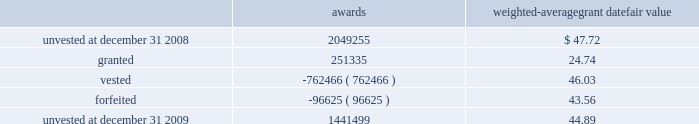Marathon oil corporation notes to consolidated financial statements restricted stock awards the following is a summary of restricted stock award activity .
Awards weighted-average grant date fair value .
The vesting date fair value of restricted stock awards which vested during 2009 , 2008 and 2007 was $ 24 million , $ 38 million and $ 29 million .
The weighted average grant date fair value of restricted stock awards was $ 44.89 , $ 47.72 , and $ 39.87 for awards unvested at december 31 , 2009 , 2008 and 2007 .
As of december 31 , 2009 , there was $ 43 million of unrecognized compensation cost related to restricted stock awards which is expected to be recognized over a weighted average period of 1.6 years .
Stock-based performance awards all stock-based performance awards have either vested or been forfeited .
The vesting date fair value of stock- based performance awards which vested during 2007 was $ 38 .
24 .
Stockholders 2019 equity in each year , 2009 and 2008 , we issued 2 million in common stock upon the redemption of the exchangeable shares described below in addition to treasury shares issued for employee stock-based awards .
The board of directors has authorized the repurchase of up to $ 5 billion of marathon common stock .
Purchases under the program may be in either open market transactions , including block purchases , or in privately negotiated transactions .
We will use cash on hand , cash generated from operations , proceeds from potential asset sales or cash from available borrowings to acquire shares .
This program may be changed based upon our financial condition or changes in market conditions and is subject to termination prior to completion .
The repurchase program does not include specific price targets or timetables .
As of december 31 , 2009 , we have acquired 66 million common shares at a cost of $ 2922 million under the program .
No shares have been acquired since august 2008 .
Securities exchangeable into marathon common stock 2013 as discussed in note 6 , we acquired all of the outstanding shares of western on october 18 , 2007 .
The western shareholders who were canadian residents received , at their election , cash , marathon common stock , securities exchangeable into marathon common stock ( the 201cexchangeable shares 201d ) or a combination thereof .
The western shareholders elected to receive 5 million exchangeable shares as part of the acquisition consideration .
The exchangeable shares are shares of an indirect canadian subsidiary of marathon and , at the acquisition date , were exchangeable on a one-for-one basis into marathon common stock .
Subsequent to the acquisition , the exchange ratio is adjusted to reflect cash dividends , if any , paid on marathon common stock and cash dividends , if any , paid on the exchangeable shares .
The exchange ratio at december 31 , 2009 , was 1.06109 common shares for each exchangeable share .
The exchangeable shares are exchangeable at the option of the holder at any time and are automatically redeemable on october 18 , 2011 .
Holders of exchangeable shares are entitled to instruct a trustee to vote ( or obtain a proxy from the trustee to vote directly ) on all matters submitted to the holders of marathon common stock .
The number of votes to which each holder is entitled is equal to the whole number of shares of marathon common stock into which such holder 2019s exchangeable shares would be exchangeable based on the exchange ratio in effect on the record date for the vote .
The voting right is attached to voting preferred shares of marathon that were issued to a trustee in an amount .
According to the above listed weighted average grant date fair value , by what percentage did the value of unvested restricted stock awards decrease from 2008 to 2009? 
Computations: (((1441499 * 44.89) - (2049255 * 47.72)) / (2049255 * 47.72))
Answer: -0.33829. Marathon oil corporation notes to consolidated financial statements restricted stock awards the following is a summary of restricted stock award activity .
Awards weighted-average grant date fair value .
The vesting date fair value of restricted stock awards which vested during 2009 , 2008 and 2007 was $ 24 million , $ 38 million and $ 29 million .
The weighted average grant date fair value of restricted stock awards was $ 44.89 , $ 47.72 , and $ 39.87 for awards unvested at december 31 , 2009 , 2008 and 2007 .
As of december 31 , 2009 , there was $ 43 million of unrecognized compensation cost related to restricted stock awards which is expected to be recognized over a weighted average period of 1.6 years .
Stock-based performance awards all stock-based performance awards have either vested or been forfeited .
The vesting date fair value of stock- based performance awards which vested during 2007 was $ 38 .
24 .
Stockholders 2019 equity in each year , 2009 and 2008 , we issued 2 million in common stock upon the redemption of the exchangeable shares described below in addition to treasury shares issued for employee stock-based awards .
The board of directors has authorized the repurchase of up to $ 5 billion of marathon common stock .
Purchases under the program may be in either open market transactions , including block purchases , or in privately negotiated transactions .
We will use cash on hand , cash generated from operations , proceeds from potential asset sales or cash from available borrowings to acquire shares .
This program may be changed based upon our financial condition or changes in market conditions and is subject to termination prior to completion .
The repurchase program does not include specific price targets or timetables .
As of december 31 , 2009 , we have acquired 66 million common shares at a cost of $ 2922 million under the program .
No shares have been acquired since august 2008 .
Securities exchangeable into marathon common stock 2013 as discussed in note 6 , we acquired all of the outstanding shares of western on october 18 , 2007 .
The western shareholders who were canadian residents received , at their election , cash , marathon common stock , securities exchangeable into marathon common stock ( the 201cexchangeable shares 201d ) or a combination thereof .
The western shareholders elected to receive 5 million exchangeable shares as part of the acquisition consideration .
The exchangeable shares are shares of an indirect canadian subsidiary of marathon and , at the acquisition date , were exchangeable on a one-for-one basis into marathon common stock .
Subsequent to the acquisition , the exchange ratio is adjusted to reflect cash dividends , if any , paid on marathon common stock and cash dividends , if any , paid on the exchangeable shares .
The exchange ratio at december 31 , 2009 , was 1.06109 common shares for each exchangeable share .
The exchangeable shares are exchangeable at the option of the holder at any time and are automatically redeemable on october 18 , 2011 .
Holders of exchangeable shares are entitled to instruct a trustee to vote ( or obtain a proxy from the trustee to vote directly ) on all matters submitted to the holders of marathon common stock .
The number of votes to which each holder is entitled is equal to the whole number of shares of marathon common stock into which such holder 2019s exchangeable shares would be exchangeable based on the exchange ratio in effect on the record date for the vote .
The voting right is attached to voting preferred shares of marathon that were issued to a trustee in an amount .
Did the vesting date fair value of restricted stock awards which vested increase between 2008 and 2009? 
Computations: (24 > 38)
Answer: no. 